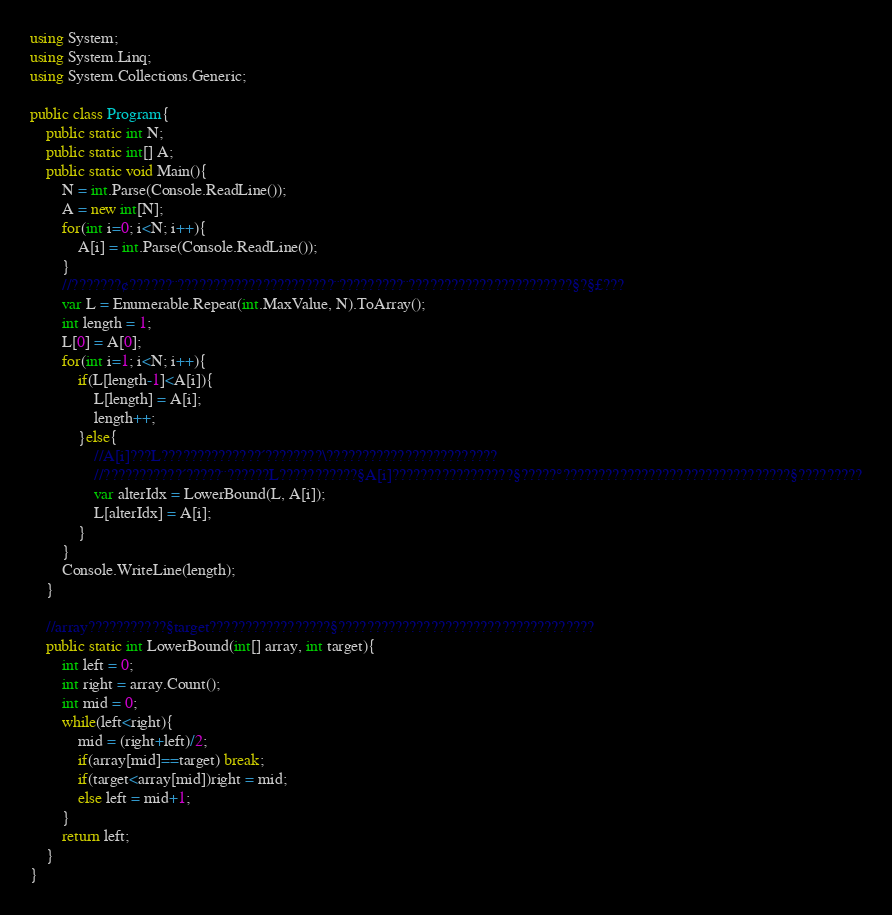Convert code to text. <code><loc_0><loc_0><loc_500><loc_500><_C#_>using System;
using System.Linq;
using System.Collections.Generic;

public class Program{
    public static int N;
    public static int[] A;
    public static void Main(){
        N = int.Parse(Console.ReadLine());
        A = new int[N];
        for(int i=0; i<N; i++){
            A[i] = int.Parse(Console.ReadLine());
        }
        //???????¢??????¨??????????????????????¨?????????¨???????????????????????§?§£???
        var L = Enumerable.Repeat(int.MaxValue, N).ToArray();
        int length = 1;
        L[0] = A[0];
        for(int i=1; i<N; i++){
            if(L[length-1]<A[i]){
                L[length] = A[i];
                length++;
            }else{
                //A[i]???L??????????????´????????\????????????????????????
                //???????????´?????¨??????L???????????§A[i]?????????????????§?????°????????????????????????????????§?????????
                var alterIdx = LowerBound(L, A[i]);
                L[alterIdx] = A[i];
            }
        }
        Console.WriteLine(length);
    }
    
    //array???????????§target?????????????????§????????????????????????????????????
    public static int LowerBound(int[] array, int target){
        int left = 0;
        int right = array.Count();
        int mid = 0;
        while(left<right){
            mid = (right+left)/2;
            if(array[mid]==target) break;
            if(target<array[mid])right = mid;
            else left = mid+1;
        }
        return left;
    }
}</code> 